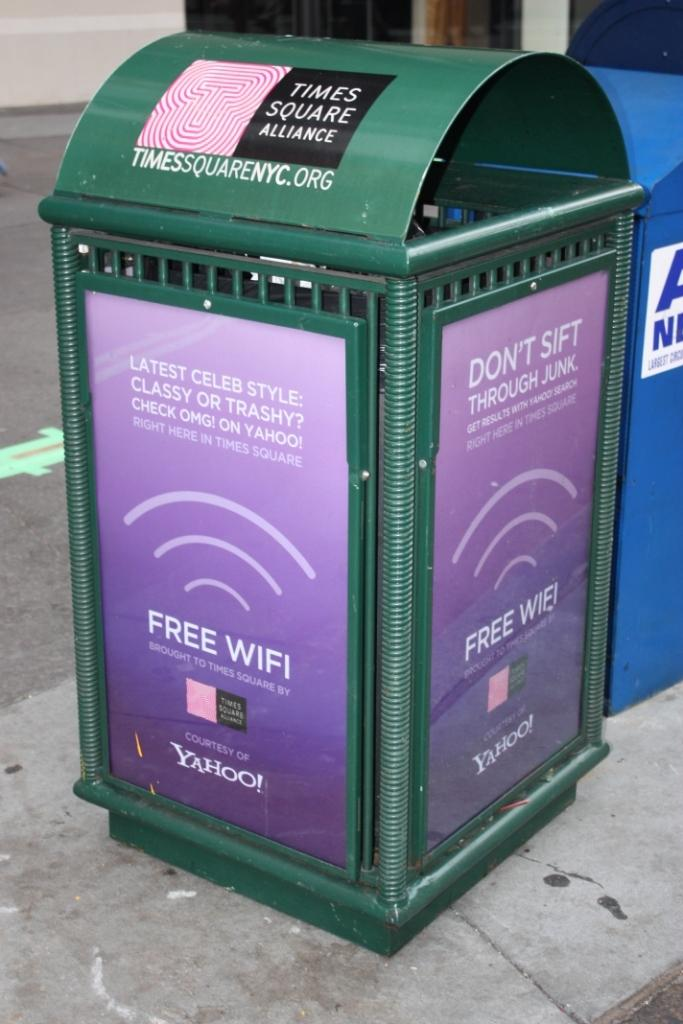Provide a one-sentence caption for the provided image. A green trash container has a purple sign with Yahoo on it. 